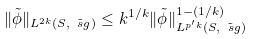<formula> <loc_0><loc_0><loc_500><loc_500>\| \tilde { \phi } \| _ { L ^ { 2 k } ( S , \tilde { \ s g } ) } \leq k ^ { 1 / k } \| \tilde { \phi } \| _ { L ^ { p ^ { \prime } k } ( S , \tilde { \ s g } ) } ^ { 1 - ( 1 / k ) }</formula> 